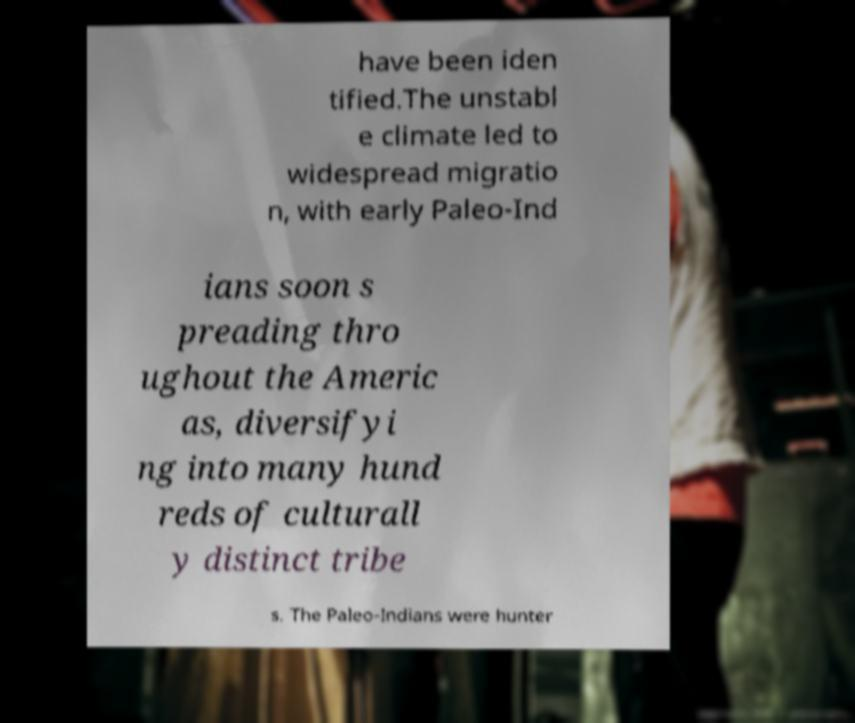Could you extract and type out the text from this image? have been iden tified.The unstabl e climate led to widespread migratio n, with early Paleo-Ind ians soon s preading thro ughout the Americ as, diversifyi ng into many hund reds of culturall y distinct tribe s. The Paleo-Indians were hunter 